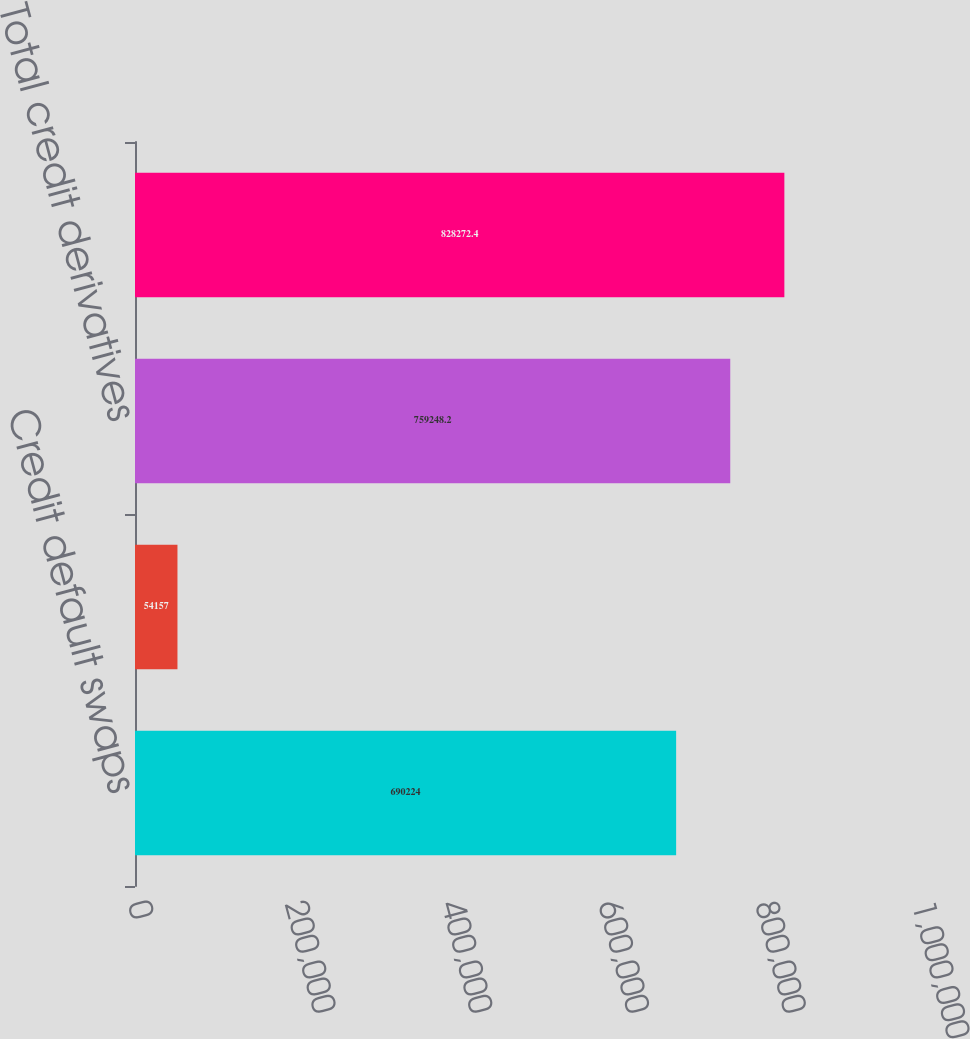<chart> <loc_0><loc_0><loc_500><loc_500><bar_chart><fcel>Credit default swaps<fcel>Other credit derivatives (a)<fcel>Total credit derivatives<fcel>Total<nl><fcel>690224<fcel>54157<fcel>759248<fcel>828272<nl></chart> 